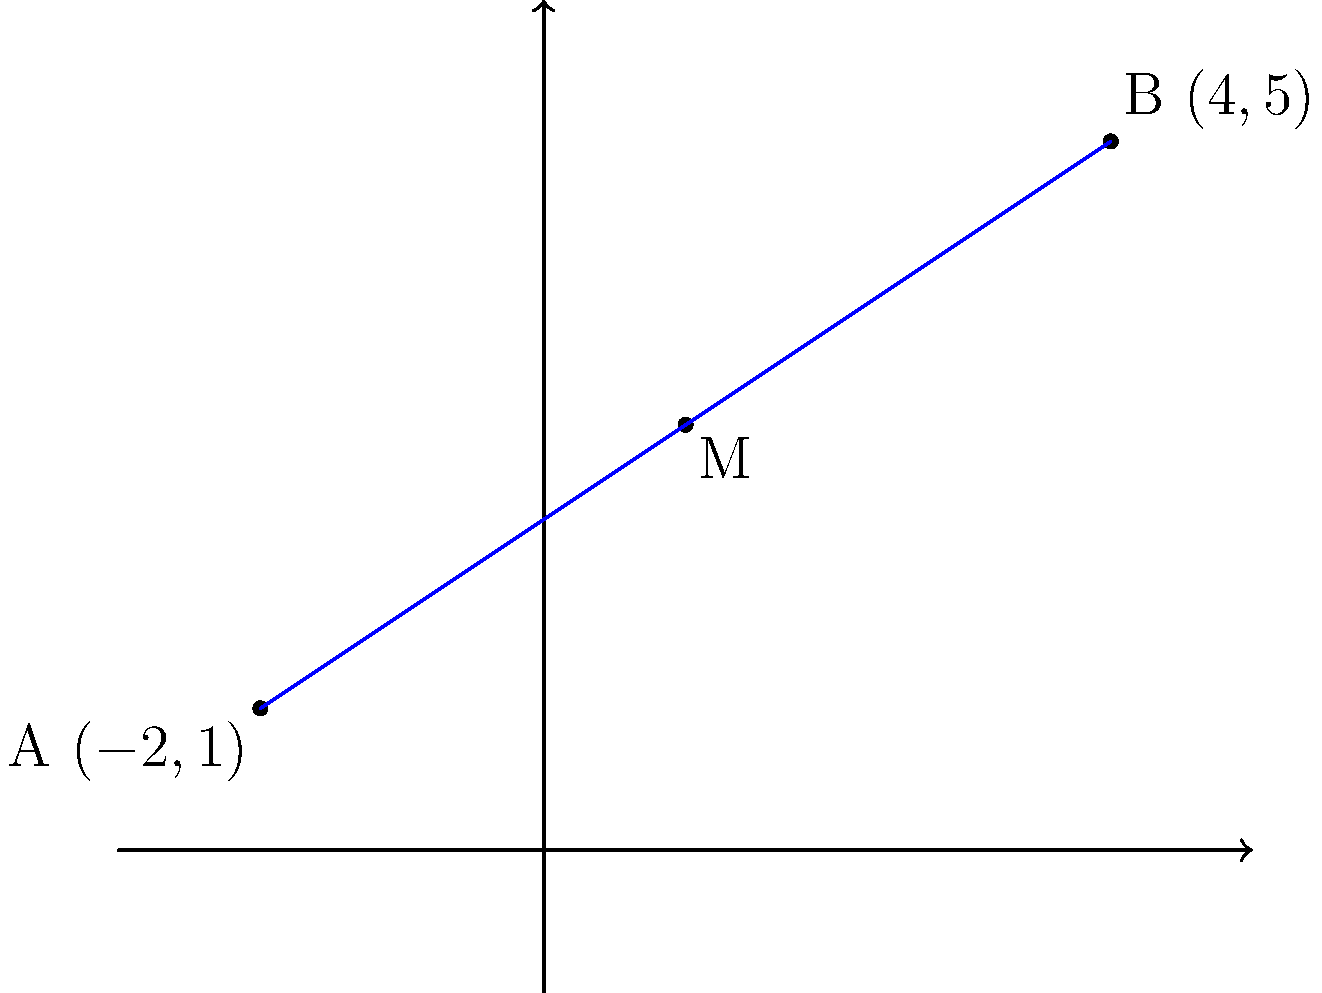Given two points $A(-2,1)$ and $B(4,5)$ on a coordinate plane, find the coordinates of the midpoint $M$ of line segment $AB$. Express your answer as a tuple in Haskell syntax. To find the midpoint of a line segment, we can use the midpoint formula:

$$ M = \left(\frac{x_1 + x_2}{2}, \frac{y_1 + y_2}{2}\right) $$

Where $(x_1, y_1)$ are the coordinates of point $A$ and $(x_2, y_2)$ are the coordinates of point $B$.

Let's apply this formula step by step:

1. Identify the coordinates:
   $A: (x_1, y_1) = (-2, 1)$
   $B: (x_2, y_2) = (4, 5)$

2. Calculate the x-coordinate of the midpoint:
   $$ x_M = \frac{x_1 + x_2}{2} = \frac{-2 + 4}{2} = \frac{2}{2} = 1 $$

3. Calculate the y-coordinate of the midpoint:
   $$ y_M = \frac{y_1 + y_2}{2} = \frac{1 + 5}{2} = \frac{6}{2} = 3 $$

4. Combine the results:
   $M(x_M, y_M) = (1, 3)$

5. Express the result as a tuple in Haskell syntax:
   $(1, 3)$

This approach can be easily implemented in Haskell using a function that takes two points as input and returns their midpoint.
Answer: (1, 3) 